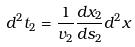<formula> <loc_0><loc_0><loc_500><loc_500>d ^ { 2 } t _ { 2 } = \frac { 1 } { v _ { 2 } } \frac { d x _ { 2 } } { d s _ { 2 } } d ^ { 2 } x</formula> 